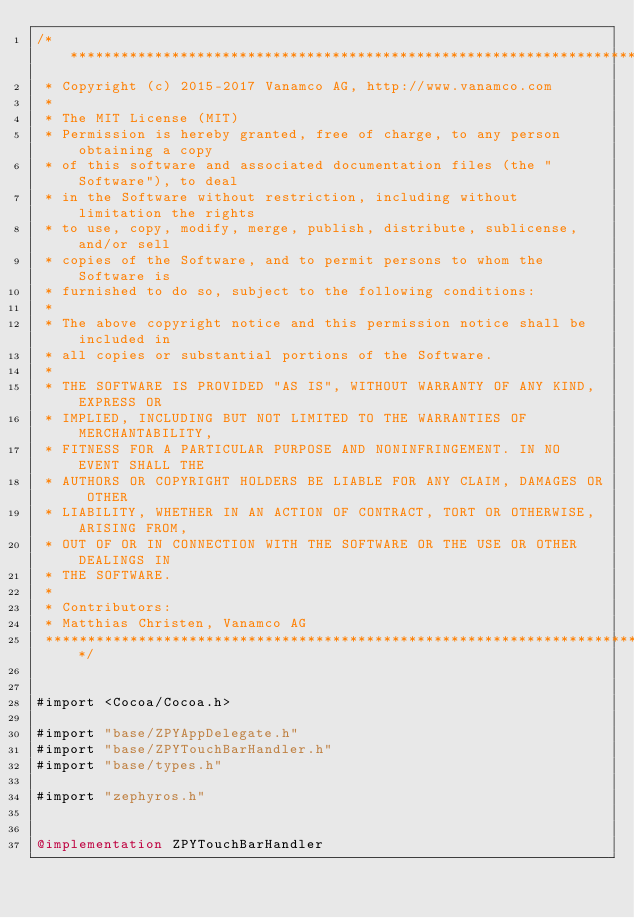<code> <loc_0><loc_0><loc_500><loc_500><_ObjectiveC_>/*******************************************************************************
 * Copyright (c) 2015-2017 Vanamco AG, http://www.vanamco.com
 *
 * The MIT License (MIT)
 * Permission is hereby granted, free of charge, to any person obtaining a copy
 * of this software and associated documentation files (the "Software"), to deal
 * in the Software without restriction, including without limitation the rights
 * to use, copy, modify, merge, publish, distribute, sublicense, and/or sell
 * copies of the Software, and to permit persons to whom the Software is
 * furnished to do so, subject to the following conditions:
 *
 * The above copyright notice and this permission notice shall be included in
 * all copies or substantial portions of the Software.
 *
 * THE SOFTWARE IS PROVIDED "AS IS", WITHOUT WARRANTY OF ANY KIND, EXPRESS OR
 * IMPLIED, INCLUDING BUT NOT LIMITED TO THE WARRANTIES OF MERCHANTABILITY,
 * FITNESS FOR A PARTICULAR PURPOSE AND NONINFRINGEMENT. IN NO EVENT SHALL THE
 * AUTHORS OR COPYRIGHT HOLDERS BE LIABLE FOR ANY CLAIM, DAMAGES OR OTHER
 * LIABILITY, WHETHER IN AN ACTION OF CONTRACT, TORT OR OTHERWISE, ARISING FROM,
 * OUT OF OR IN CONNECTION WITH THE SOFTWARE OR THE USE OR OTHER DEALINGS IN
 * THE SOFTWARE.
 *
 * Contributors:
 * Matthias Christen, Vanamco AG
 *******************************************************************************/


#import <Cocoa/Cocoa.h>

#import "base/ZPYAppDelegate.h"
#import "base/ZPYTouchBarHandler.h"
#import "base/types.h"

#import "zephyros.h"


@implementation ZPYTouchBarHandler
</code> 